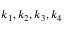<formula> <loc_0><loc_0><loc_500><loc_500>k _ { 1 } , k _ { 2 } , k _ { 3 } , k _ { 4 }</formula> 